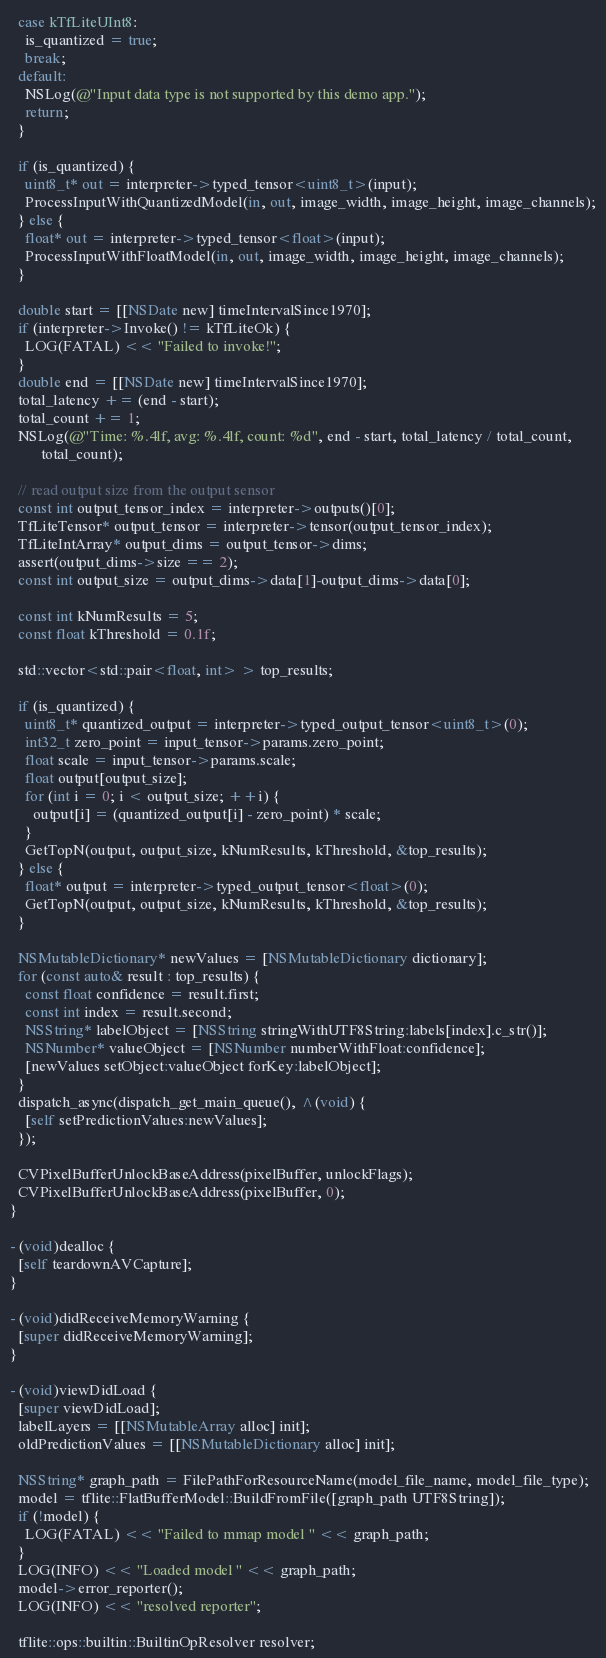<code> <loc_0><loc_0><loc_500><loc_500><_ObjectiveC_>  case kTfLiteUInt8:
    is_quantized = true;
    break;
  default:
    NSLog(@"Input data type is not supported by this demo app.");
    return;
  }

  if (is_quantized) {
    uint8_t* out = interpreter->typed_tensor<uint8_t>(input);
    ProcessInputWithQuantizedModel(in, out, image_width, image_height, image_channels);
  } else {
    float* out = interpreter->typed_tensor<float>(input);
    ProcessInputWithFloatModel(in, out, image_width, image_height, image_channels);
  }

  double start = [[NSDate new] timeIntervalSince1970];
  if (interpreter->Invoke() != kTfLiteOk) {
    LOG(FATAL) << "Failed to invoke!";
  }
  double end = [[NSDate new] timeIntervalSince1970];
  total_latency += (end - start);
  total_count += 1;
  NSLog(@"Time: %.4lf, avg: %.4lf, count: %d", end - start, total_latency / total_count,
        total_count);

  // read output size from the output sensor
  const int output_tensor_index = interpreter->outputs()[0];
  TfLiteTensor* output_tensor = interpreter->tensor(output_tensor_index);
  TfLiteIntArray* output_dims = output_tensor->dims;
  assert(output_dims->size == 2);
  const int output_size = output_dims->data[1]-output_dims->data[0];
    
  const int kNumResults = 5;
  const float kThreshold = 0.1f;

  std::vector<std::pair<float, int> > top_results;

  if (is_quantized) {
    uint8_t* quantized_output = interpreter->typed_output_tensor<uint8_t>(0);
    int32_t zero_point = input_tensor->params.zero_point;
    float scale = input_tensor->params.scale;
    float output[output_size];
    for (int i = 0; i < output_size; ++i) {
      output[i] = (quantized_output[i] - zero_point) * scale;
    }
    GetTopN(output, output_size, kNumResults, kThreshold, &top_results);
  } else {
    float* output = interpreter->typed_output_tensor<float>(0);
    GetTopN(output, output_size, kNumResults, kThreshold, &top_results);
  }

  NSMutableDictionary* newValues = [NSMutableDictionary dictionary];
  for (const auto& result : top_results) {
    const float confidence = result.first;
    const int index = result.second;
    NSString* labelObject = [NSString stringWithUTF8String:labels[index].c_str()];
    NSNumber* valueObject = [NSNumber numberWithFloat:confidence];
    [newValues setObject:valueObject forKey:labelObject];
  }
  dispatch_async(dispatch_get_main_queue(), ^(void) {
    [self setPredictionValues:newValues];
  });

  CVPixelBufferUnlockBaseAddress(pixelBuffer, unlockFlags);
  CVPixelBufferUnlockBaseAddress(pixelBuffer, 0);
}

- (void)dealloc {
  [self teardownAVCapture];
}

- (void)didReceiveMemoryWarning {
  [super didReceiveMemoryWarning];
}

- (void)viewDidLoad {
  [super viewDidLoad];
  labelLayers = [[NSMutableArray alloc] init];
  oldPredictionValues = [[NSMutableDictionary alloc] init];

  NSString* graph_path = FilePathForResourceName(model_file_name, model_file_type);
  model = tflite::FlatBufferModel::BuildFromFile([graph_path UTF8String]);
  if (!model) {
    LOG(FATAL) << "Failed to mmap model " << graph_path;
  }
  LOG(INFO) << "Loaded model " << graph_path;
  model->error_reporter();
  LOG(INFO) << "resolved reporter";

  tflite::ops::builtin::BuiltinOpResolver resolver;</code> 